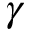<formula> <loc_0><loc_0><loc_500><loc_500>\gamma</formula> 